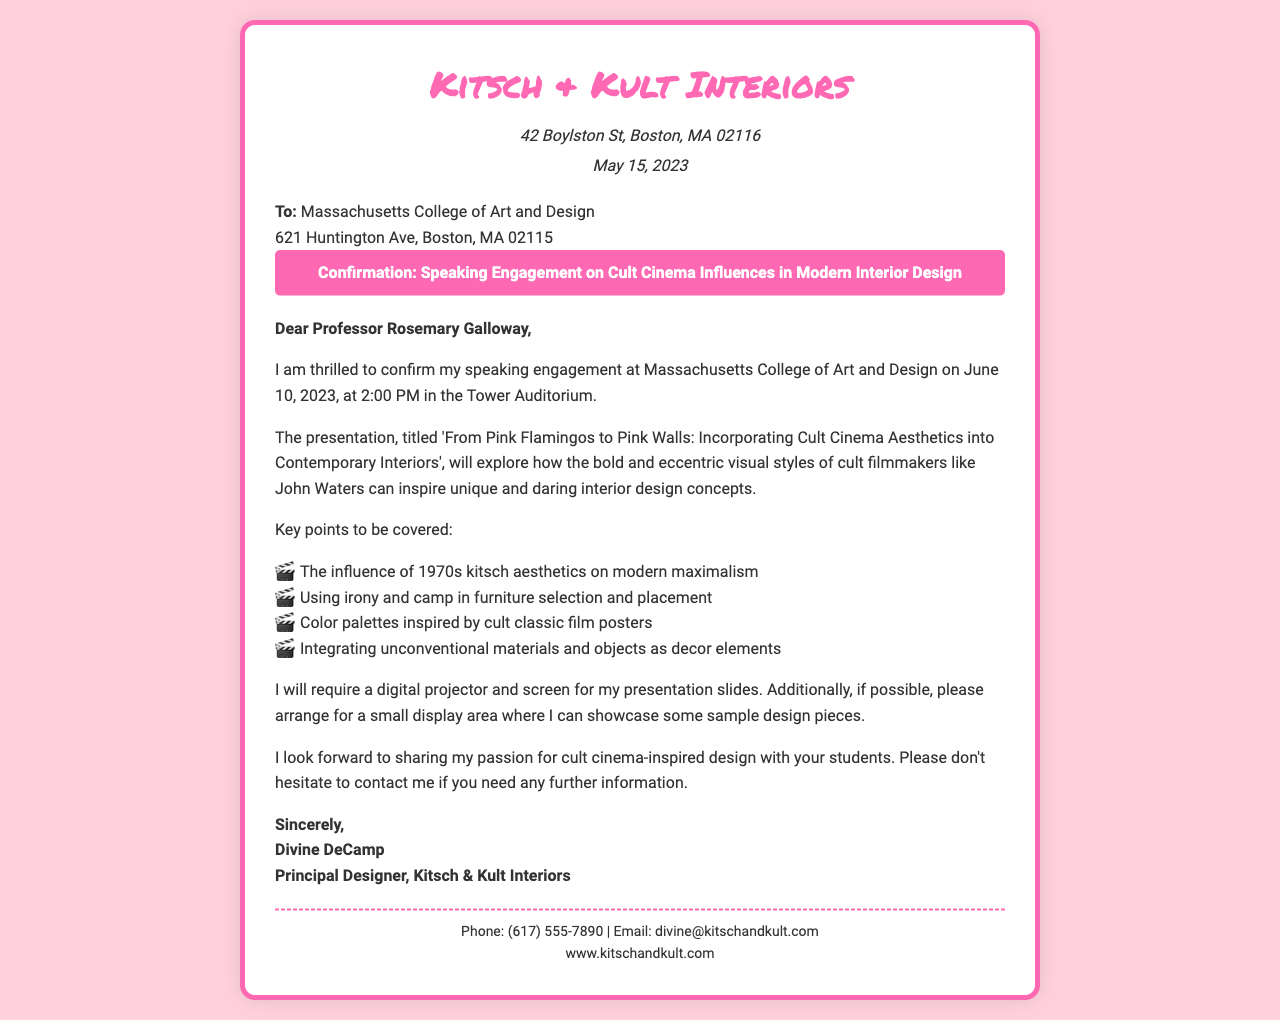What is the name of the design firm? The name of the design firm is mentioned in the header of the document.
Answer: Kitsch & Kult Interiors What is the date of the speaking engagement? The date is specified in the main content of the document under the opening greeting.
Answer: June 10, 2023 What time will the presentation start? The time is stated in the same section as the date of the speaking engagement.
Answer: 2:00 PM Who is the recipient of the fax? The fax is addressed to someone specifically named in the document.
Answer: Professor Rosemary Galloway What is the title of the presentation? The title is highlighted in the main content of the document.
Answer: From Pink Flamingos to Pink Walls: Incorporating Cult Cinema Aesthetics into Contemporary Interiors What equipment will the speaker require? The document specifies a need for an item that is necessary for the presentation.
Answer: Digital projector and screen How many key points will be covered in the presentation? The number of points is implied by checking the list of key points provided.
Answer: Four What is the theme of the presentation? The theme relates to the influences discussed in the presentation title.
Answer: Cult cinema aesthetics What is the address of the design school? The address of the recipient is listed in the document.
Answer: 621 Huntington Ave, Boston, MA 02115 What type of design concepts will be explored? The focus on design concepts is evident in the description of the presentation.
Answer: Unique and daring interior design concepts 